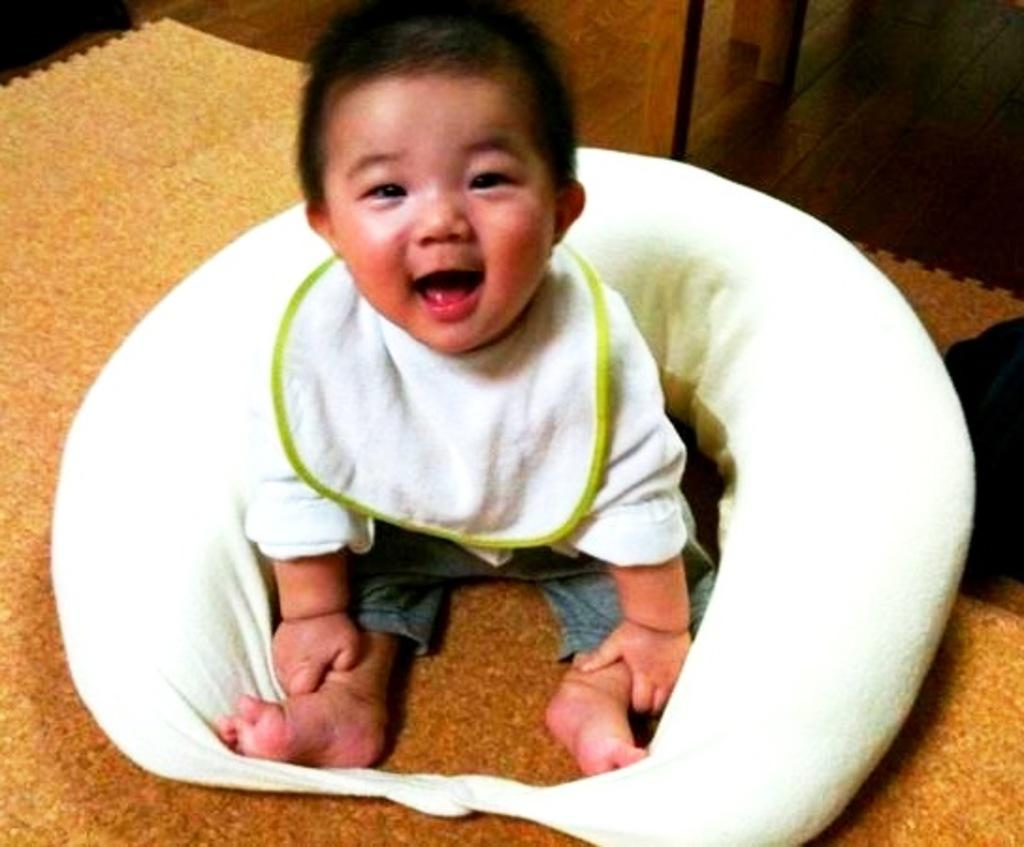Who is the main subject in the picture? There is a boy in the picture. What is the boy doing in the picture? The boy is sitting on a mat. What is the boy's facial expression in the picture? The boy is smiling. What type of riddle is the boy solving in the picture? There is no riddle present in the image; the boy is simply sitting on a mat and smiling. 